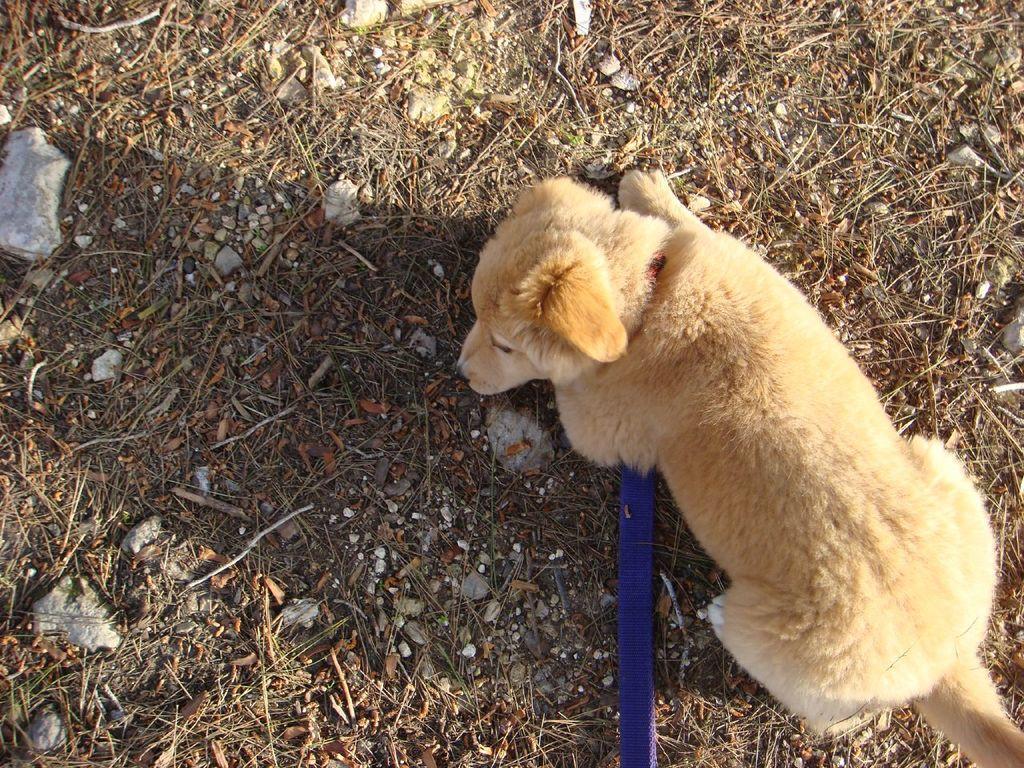How would you summarize this image in a sentence or two? In this picture, we see a dog. We see the leash of the dog in blue color. In the background, we see the stones, dry leaves and the twigs. 